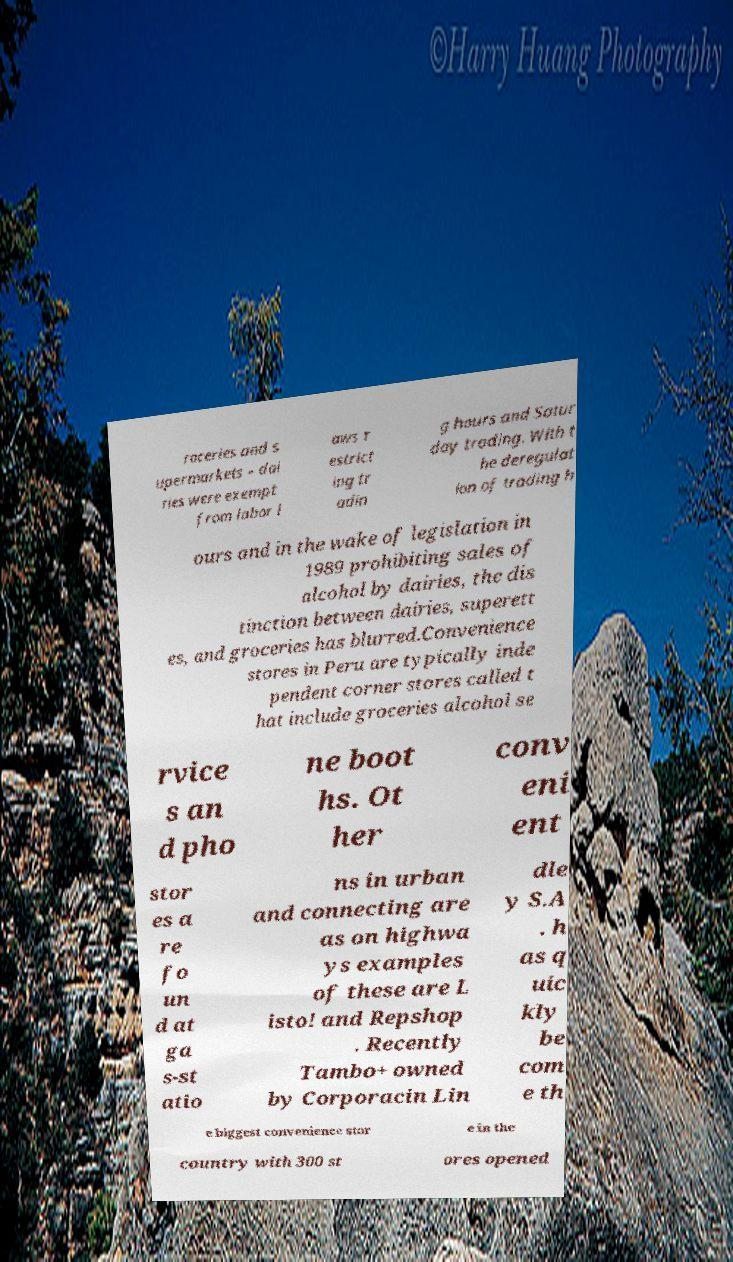Can you accurately transcribe the text from the provided image for me? roceries and s upermarkets – dai ries were exempt from labor l aws r estrict ing tr adin g hours and Satur day trading. With t he deregulat ion of trading h ours and in the wake of legislation in 1989 prohibiting sales of alcohol by dairies, the dis tinction between dairies, superett es, and groceries has blurred.Convenience stores in Peru are typically inde pendent corner stores called t hat include groceries alcohol se rvice s an d pho ne boot hs. Ot her conv eni ent stor es a re fo un d at ga s-st atio ns in urban and connecting are as on highwa ys examples of these are L isto! and Repshop . Recently Tambo+ owned by Corporacin Lin dle y S.A . h as q uic kly be com e th e biggest convenience stor e in the country with 300 st ores opened 